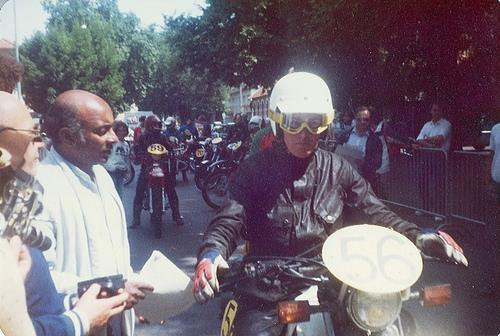Mention the central focus and actions taking place in the photograph. A man wearing a white helmet and yellow goggles is riding a motorcycle, with a bald man holding white papers standing beside him. Summarize the core subjects and happenings in the picture. A motorcyclist in a white helmet, a bald man with papers, and background cyclists and viewers are the main subjects of the picture. Explain the primary focus and ongoing events within the photograph. The primary focus is a man in a white helmet riding a motorcycle, with a bald man holding papers and background cyclists and watchers. Identify the primary subjects and their ongoing activities within the image. The primary subjects are a motorcyclist wearing a white helmet and a bald man holding papers, with other people on bikes and spectators in the background. What are the key elements and activities present in the image? Key elements are a man in a white helmet riding a motorcycle, a bald man with white papers, and others cycling in the background. State the main subject and actions occurring in the image. The image shows a man riding a motorcycle wearing a white helmet, a bald man holding white papers, and cyclists with spectators in the background. Describe the central figures and interactions in the image. Central figures include a man with a white helmet on a motorcycle and a bald man holding papers, with other cyclists and bystanders in the background. Briefly describe the primary focus and events happening in the photo. In the photo, a man with a white helmet rides a motorcycle while a bald man holds some papers, with cyclists and onlookers in the backdrop. Outline the central theme and actions in the image. A helmeted motorcyclist and a bald man holding papers feature prominently, with other bikers and observers in the background. Depict the main scenario in the picture including the actions of the characters. The main scenario features a biker with a white helmet and a bald man holding papers, with other cyclists and a fence with spectators in the background. The trees against the sky are pink. The trees are described as green, making the assertion that they are pink misleading. The man is holding a red paper. The man is said to be holding a white paper, not red, so this instruction is misleading. There is a dark-colored fence behind the people. There is no mention of a dark-colored fence in any of the captions, so this instruction is misleading. The light on the bike is blue. There is no mention of the light color, but it is described as being off, so suggesting it is blue is misleading. Does the contestant have the number 8? The contestant has the number 5, not 8, so this instruction is misleading. Are the goggles on the biker purple? The goggles are described as yellow multiple times, making the mention of them being purple misleading. Notice the green jacket on the man. The jacket on the man is described as black, not green, so this instruction is misleading. Can you find the woman on the bicycle? There is only mention of a man on a bicycle, so suggesting there is a woman on the bicycle is misleading. Is the helmet on the biker red? The helmet on the biker is described as white in multiple captions, therefore describing it as red is misleading. Can you see the dog near the bikes? There is no mention of a dog in any of the captions, so this instruction is misleading. 